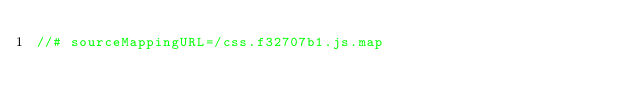Convert code to text. <code><loc_0><loc_0><loc_500><loc_500><_JavaScript_>//# sourceMappingURL=/css.f32707b1.js.map</code> 